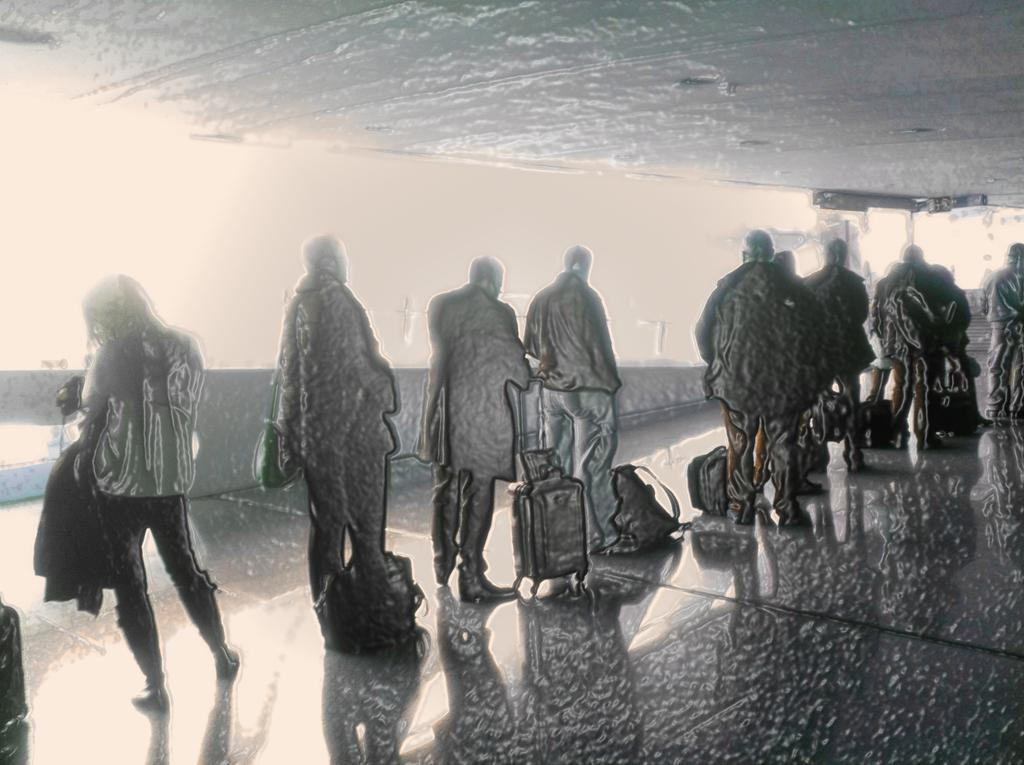What type of picture is in the image? The image contains an edited picture. Can you describe the subjects in the image? There are people in the image. What objects are present in the image? There are bags in the image. What surface can be seen in the image? There is a floor visible in the image. Where is the baby located in the image? There is no baby present in the image. What type of room is shown in the image? The image does not depict a room; it contains an edited picture with people and bags. 